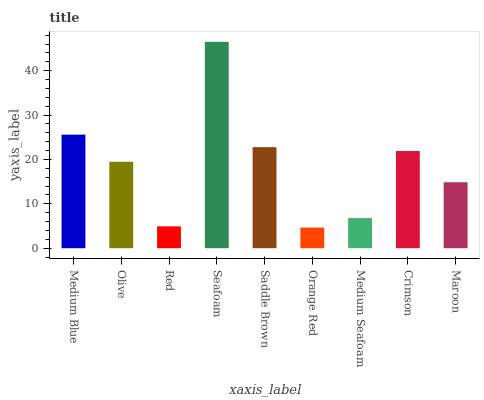Is Orange Red the minimum?
Answer yes or no. Yes. Is Seafoam the maximum?
Answer yes or no. Yes. Is Olive the minimum?
Answer yes or no. No. Is Olive the maximum?
Answer yes or no. No. Is Medium Blue greater than Olive?
Answer yes or no. Yes. Is Olive less than Medium Blue?
Answer yes or no. Yes. Is Olive greater than Medium Blue?
Answer yes or no. No. Is Medium Blue less than Olive?
Answer yes or no. No. Is Olive the high median?
Answer yes or no. Yes. Is Olive the low median?
Answer yes or no. Yes. Is Medium Seafoam the high median?
Answer yes or no. No. Is Saddle Brown the low median?
Answer yes or no. No. 